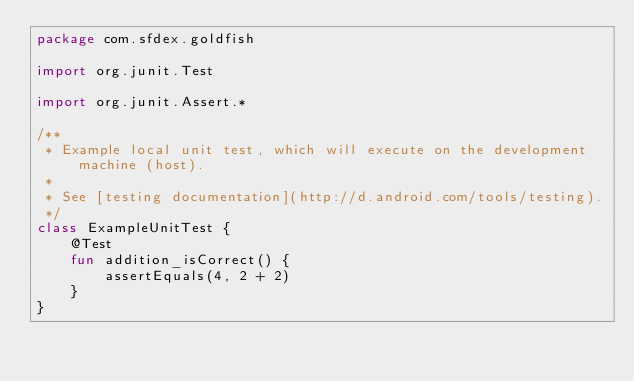Convert code to text. <code><loc_0><loc_0><loc_500><loc_500><_Kotlin_>package com.sfdex.goldfish

import org.junit.Test

import org.junit.Assert.*

/**
 * Example local unit test, which will execute on the development machine (host).
 *
 * See [testing documentation](http://d.android.com/tools/testing).
 */
class ExampleUnitTest {
    @Test
    fun addition_isCorrect() {
        assertEquals(4, 2 + 2)
    }
}</code> 